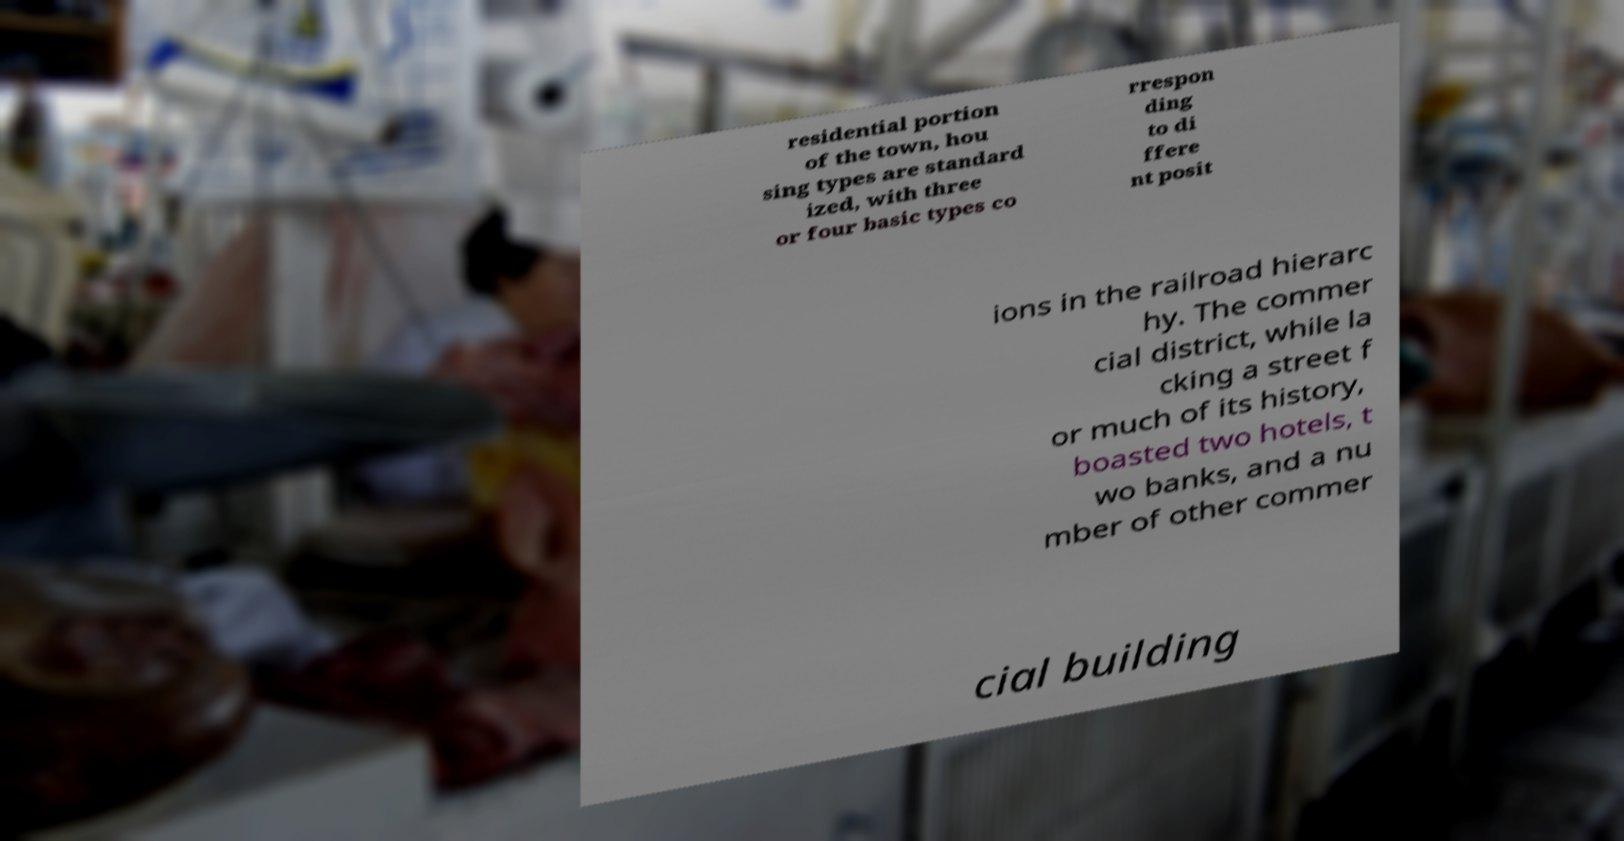I need the written content from this picture converted into text. Can you do that? residential portion of the town, hou sing types are standard ized, with three or four basic types co rrespon ding to di ffere nt posit ions in the railroad hierarc hy. The commer cial district, while la cking a street f or much of its history, boasted two hotels, t wo banks, and a nu mber of other commer cial building 